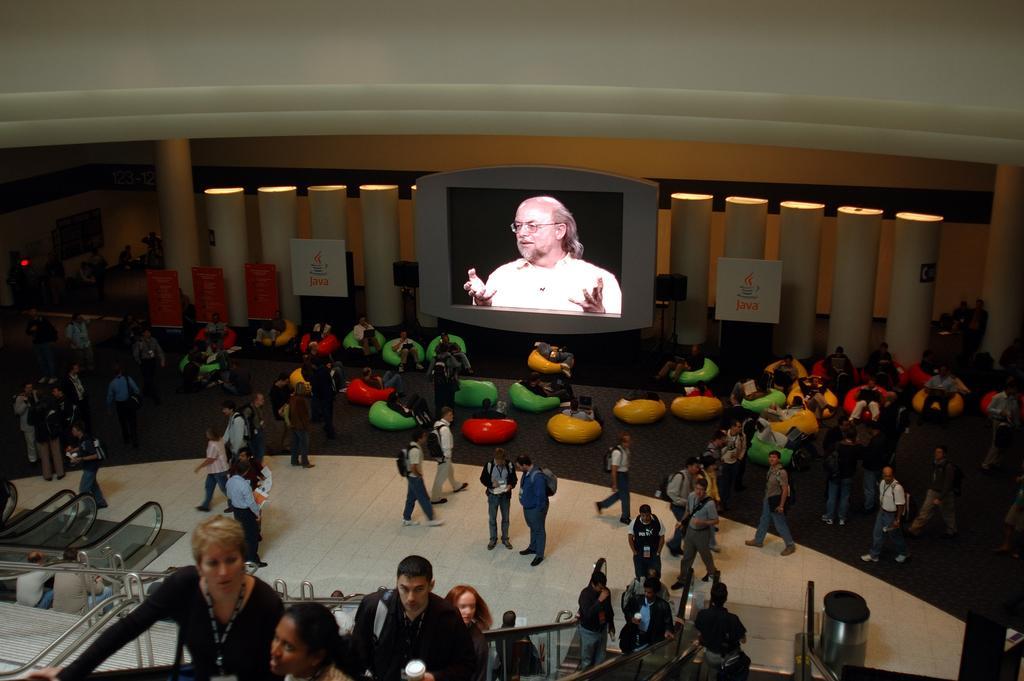Can you describe this image briefly? In this picture there is a projector and there are group of people sitting on an object and the remaining are standing and there are few people standing on an escalator and there are two persons sitting in the left corner and there are some other objects in the background. 